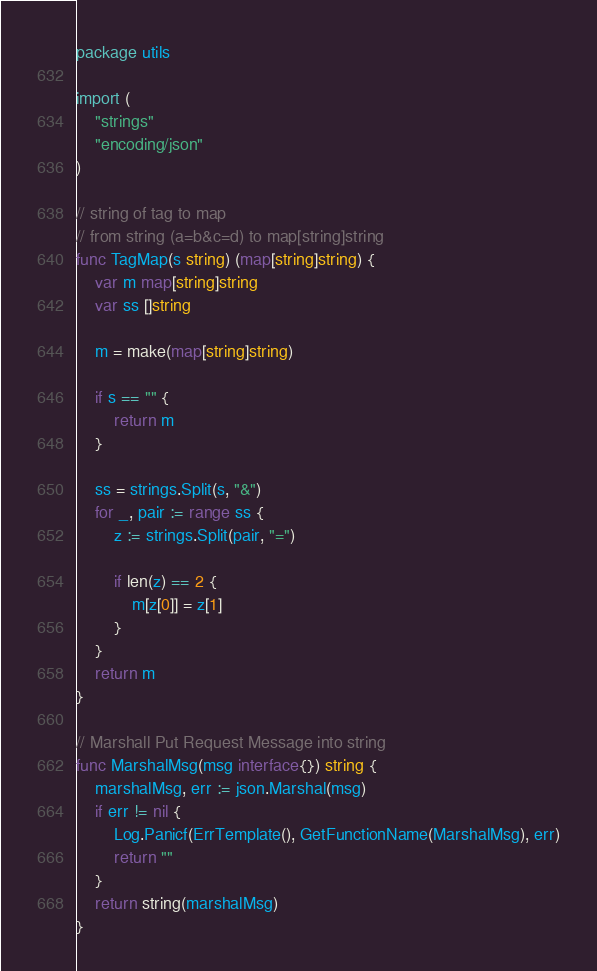<code> <loc_0><loc_0><loc_500><loc_500><_Go_>package utils

import (
	"strings"
	"encoding/json"
)

// string of tag to map
// from string (a=b&c=d) to map[string]string
func TagMap(s string) (map[string]string) {
	var m map[string]string
	var ss []string

	m = make(map[string]string)

	if s == "" {
		return m
	}

	ss = strings.Split(s, "&")
	for _, pair := range ss {
		z := strings.Split(pair, "=")

		if len(z) == 2 {
			m[z[0]] = z[1]
		}
	}
	return m
}

// Marshall Put Request Message into string
func MarshalMsg(msg interface{}) string {
	marshalMsg, err := json.Marshal(msg)
	if err != nil {
		Log.Panicf(ErrTemplate(), GetFunctionName(MarshalMsg), err)
		return ""
	}
	return string(marshalMsg)
}
</code> 